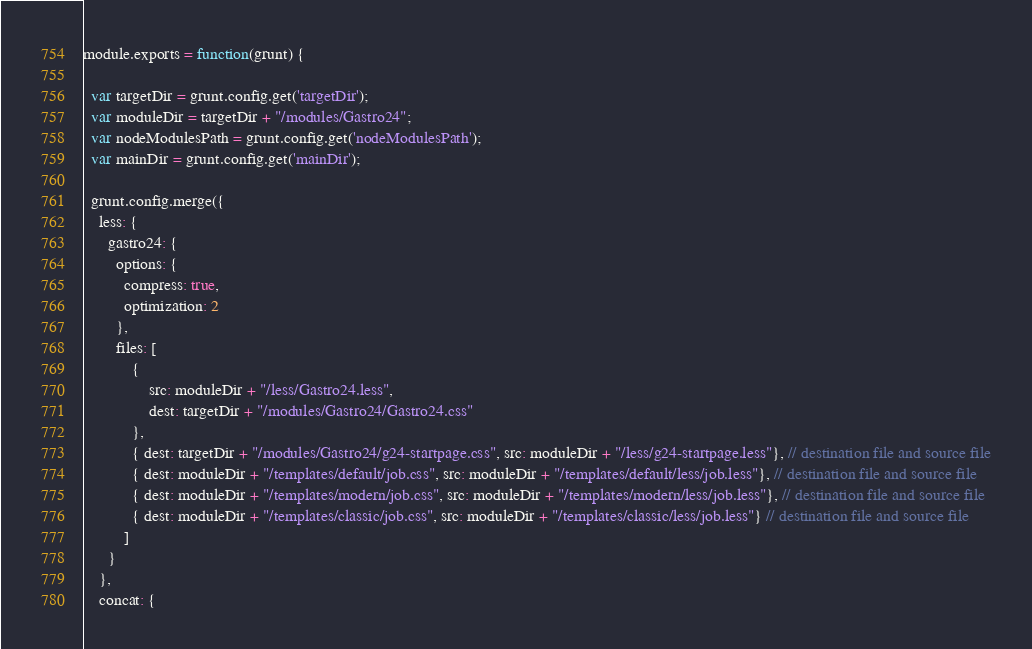Convert code to text. <code><loc_0><loc_0><loc_500><loc_500><_JavaScript_>module.exports = function(grunt) {

  var targetDir = grunt.config.get('targetDir');
  var moduleDir = targetDir + "/modules/Gastro24";
  var nodeModulesPath = grunt.config.get('nodeModulesPath');
  var mainDir = grunt.config.get('mainDir');

  grunt.config.merge({
    less: {
      gastro24: {
        options: {
          compress: true,
          optimization: 2
        },
        files: [
            {
                src: moduleDir + "/less/Gastro24.less",
                dest: targetDir + "/modules/Gastro24/Gastro24.css"
            },
            { dest: targetDir + "/modules/Gastro24/g24-startpage.css", src: moduleDir + "/less/g24-startpage.less"}, // destination file and source file
            { dest: moduleDir + "/templates/default/job.css", src: moduleDir + "/templates/default/less/job.less"}, // destination file and source file
            { dest: moduleDir + "/templates/modern/job.css", src: moduleDir + "/templates/modern/less/job.less"}, // destination file and source file
            { dest: moduleDir + "/templates/classic/job.css", src: moduleDir + "/templates/classic/less/job.less"} // destination file and source file
          ]
      }
    },
    concat: {</code> 